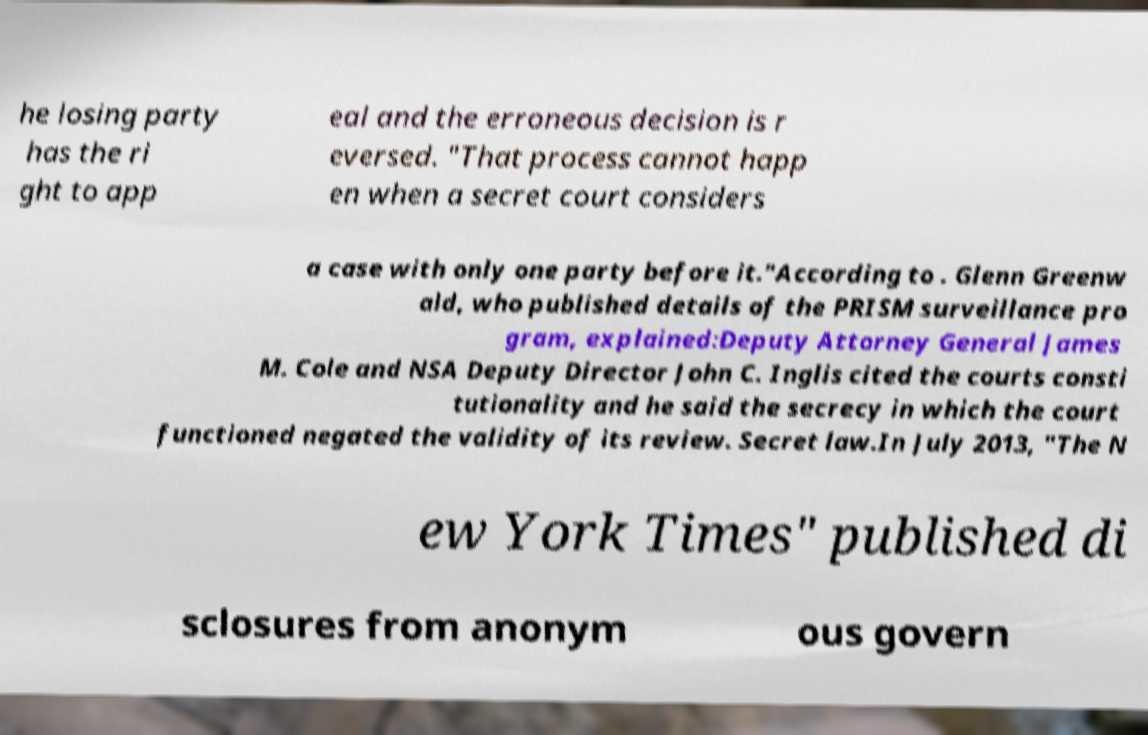What messages or text are displayed in this image? I need them in a readable, typed format. he losing party has the ri ght to app eal and the erroneous decision is r eversed. "That process cannot happ en when a secret court considers a case with only one party before it."According to . Glenn Greenw ald, who published details of the PRISM surveillance pro gram, explained:Deputy Attorney General James M. Cole and NSA Deputy Director John C. Inglis cited the courts consti tutionality and he said the secrecy in which the court functioned negated the validity of its review. Secret law.In July 2013, "The N ew York Times" published di sclosures from anonym ous govern 